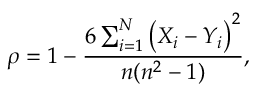<formula> <loc_0><loc_0><loc_500><loc_500>\rho = 1 - \frac { 6 \sum _ { i = 1 } ^ { N } \left ( X _ { i } - Y _ { i } \right ) ^ { 2 } } { n ( n ^ { 2 } - 1 ) } ,</formula> 